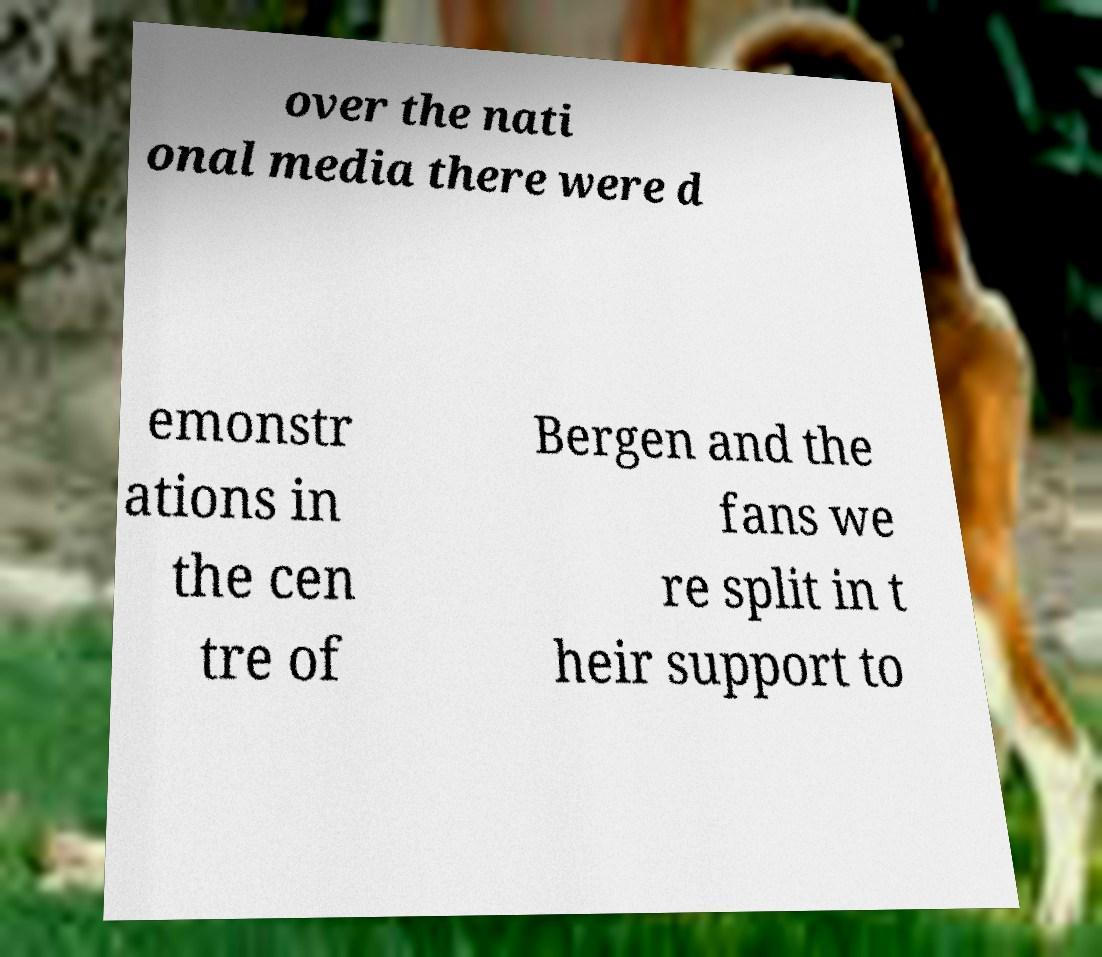What messages or text are displayed in this image? I need them in a readable, typed format. over the nati onal media there were d emonstr ations in the cen tre of Bergen and the fans we re split in t heir support to 